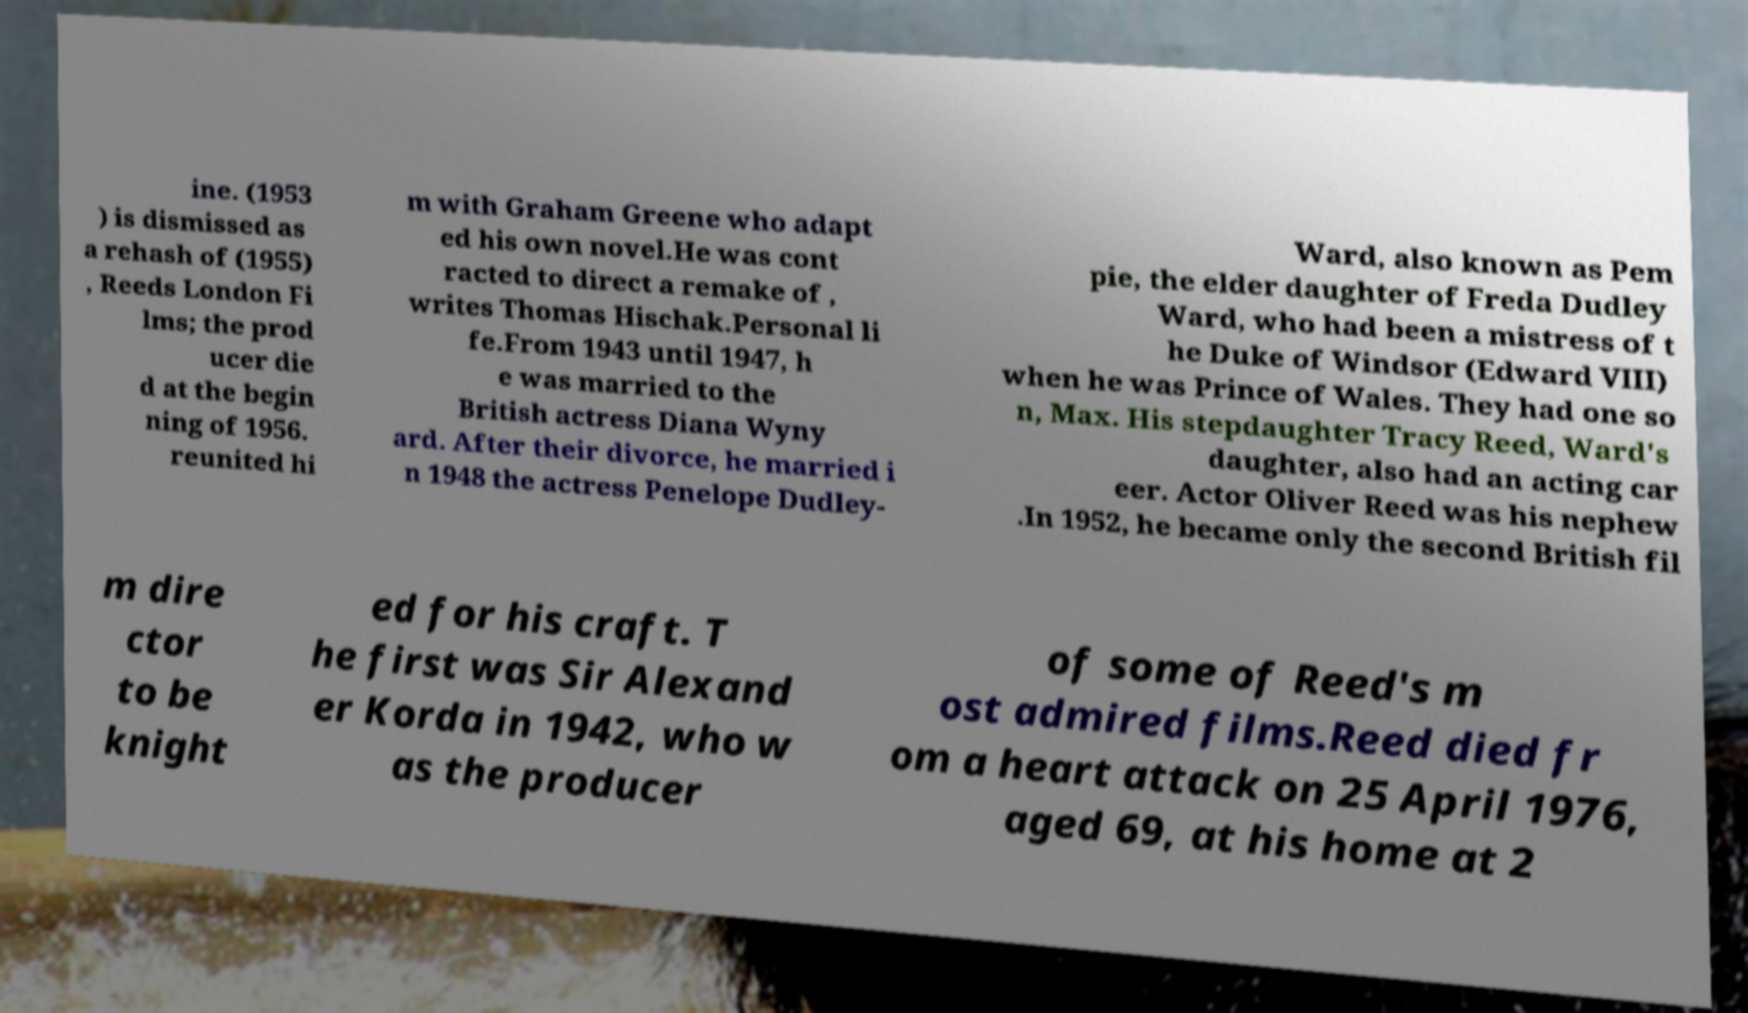Please read and relay the text visible in this image. What does it say? ine. (1953 ) is dismissed as a rehash of (1955) , Reeds London Fi lms; the prod ucer die d at the begin ning of 1956. reunited hi m with Graham Greene who adapt ed his own novel.He was cont racted to direct a remake of , writes Thomas Hischak.Personal li fe.From 1943 until 1947, h e was married to the British actress Diana Wyny ard. After their divorce, he married i n 1948 the actress Penelope Dudley- Ward, also known as Pem pie, the elder daughter of Freda Dudley Ward, who had been a mistress of t he Duke of Windsor (Edward VIII) when he was Prince of Wales. They had one so n, Max. His stepdaughter Tracy Reed, Ward's daughter, also had an acting car eer. Actor Oliver Reed was his nephew .In 1952, he became only the second British fil m dire ctor to be knight ed for his craft. T he first was Sir Alexand er Korda in 1942, who w as the producer of some of Reed's m ost admired films.Reed died fr om a heart attack on 25 April 1976, aged 69, at his home at 2 